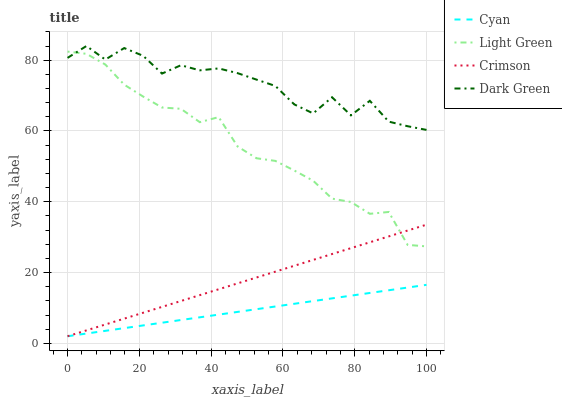Does Cyan have the minimum area under the curve?
Answer yes or no. Yes. Does Dark Green have the maximum area under the curve?
Answer yes or no. Yes. Does Light Green have the minimum area under the curve?
Answer yes or no. No. Does Light Green have the maximum area under the curve?
Answer yes or no. No. Is Cyan the smoothest?
Answer yes or no. Yes. Is Dark Green the roughest?
Answer yes or no. Yes. Is Light Green the smoothest?
Answer yes or no. No. Is Light Green the roughest?
Answer yes or no. No. Does Crimson have the lowest value?
Answer yes or no. Yes. Does Light Green have the lowest value?
Answer yes or no. No. Does Dark Green have the highest value?
Answer yes or no. Yes. Does Light Green have the highest value?
Answer yes or no. No. Is Cyan less than Light Green?
Answer yes or no. Yes. Is Light Green greater than Cyan?
Answer yes or no. Yes. Does Light Green intersect Crimson?
Answer yes or no. Yes. Is Light Green less than Crimson?
Answer yes or no. No. Is Light Green greater than Crimson?
Answer yes or no. No. Does Cyan intersect Light Green?
Answer yes or no. No. 